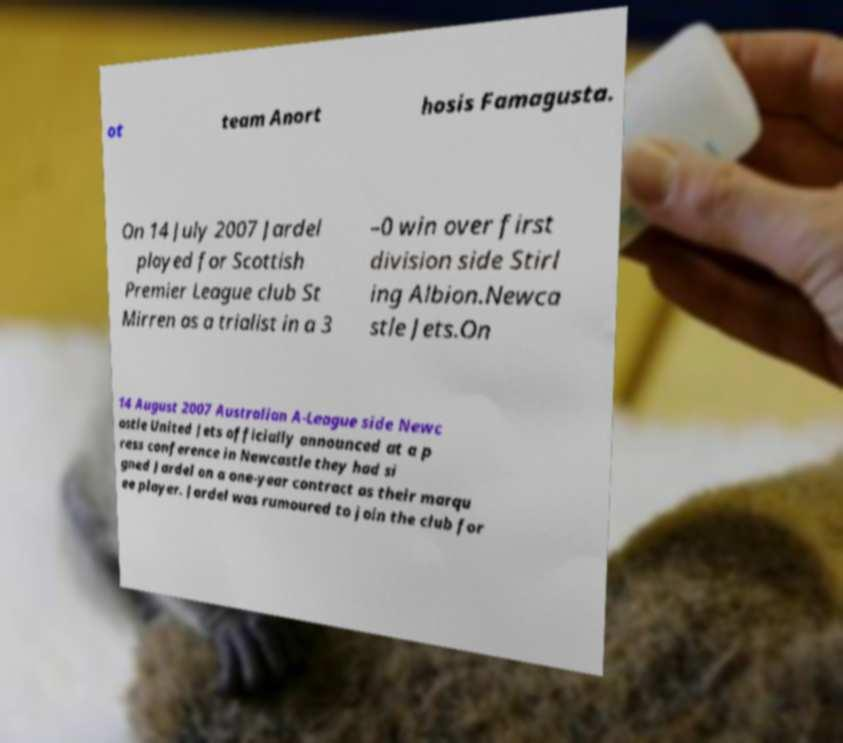Can you read and provide the text displayed in the image?This photo seems to have some interesting text. Can you extract and type it out for me? ot team Anort hosis Famagusta. On 14 July 2007 Jardel played for Scottish Premier League club St Mirren as a trialist in a 3 –0 win over first division side Stirl ing Albion.Newca stle Jets.On 14 August 2007 Australian A-League side Newc astle United Jets officially announced at a p ress conference in Newcastle they had si gned Jardel on a one-year contract as their marqu ee player. Jardel was rumoured to join the club for 